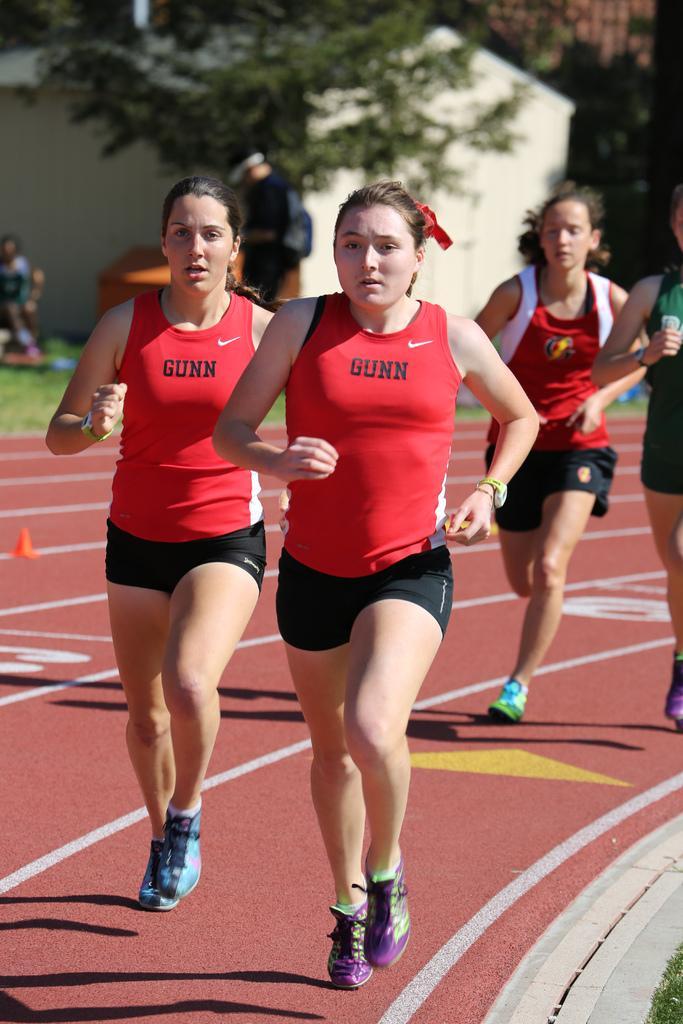How would you summarize this image in a sentence or two? Here we can see few persons are running on the ground. In the background there is a house, trees, few persons and other objects. 